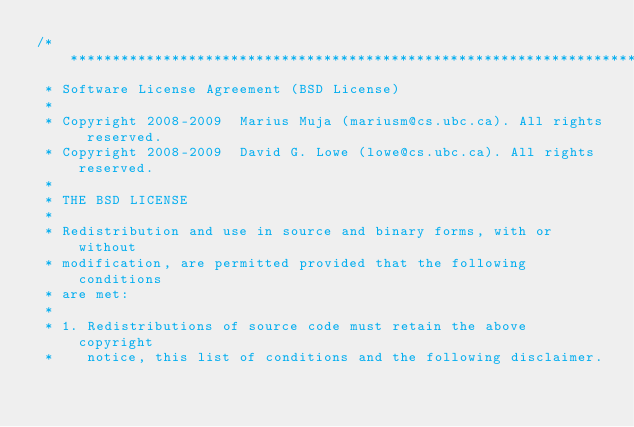<code> <loc_0><loc_0><loc_500><loc_500><_C_>/***********************************************************************
 * Software License Agreement (BSD License)
 *
 * Copyright 2008-2009  Marius Muja (mariusm@cs.ubc.ca). All rights reserved.
 * Copyright 2008-2009  David G. Lowe (lowe@cs.ubc.ca). All rights reserved.
 *
 * THE BSD LICENSE
 *
 * Redistribution and use in source and binary forms, with or without
 * modification, are permitted provided that the following conditions
 * are met:
 *
 * 1. Redistributions of source code must retain the above copyright
 *    notice, this list of conditions and the following disclaimer.</code> 